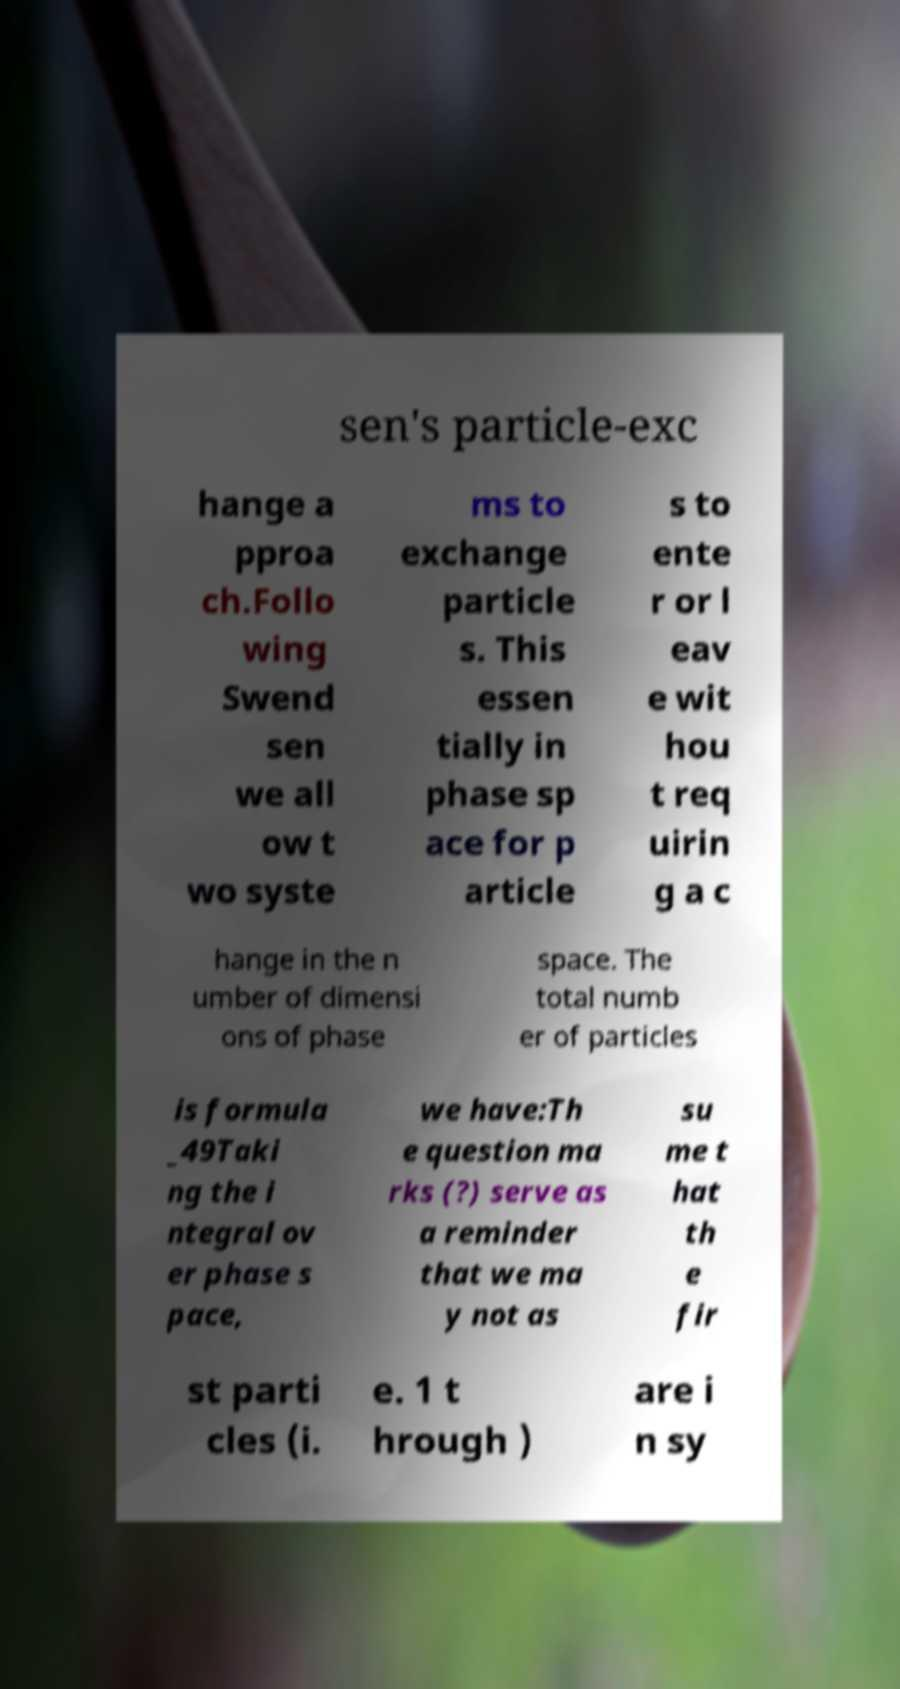Can you accurately transcribe the text from the provided image for me? sen's particle-exc hange a pproa ch.Follo wing Swend sen we all ow t wo syste ms to exchange particle s. This essen tially in phase sp ace for p article s to ente r or l eav e wit hou t req uirin g a c hange in the n umber of dimensi ons of phase space. The total numb er of particles is formula _49Taki ng the i ntegral ov er phase s pace, we have:Th e question ma rks (?) serve as a reminder that we ma y not as su me t hat th e fir st parti cles (i. e. 1 t hrough ) are i n sy 